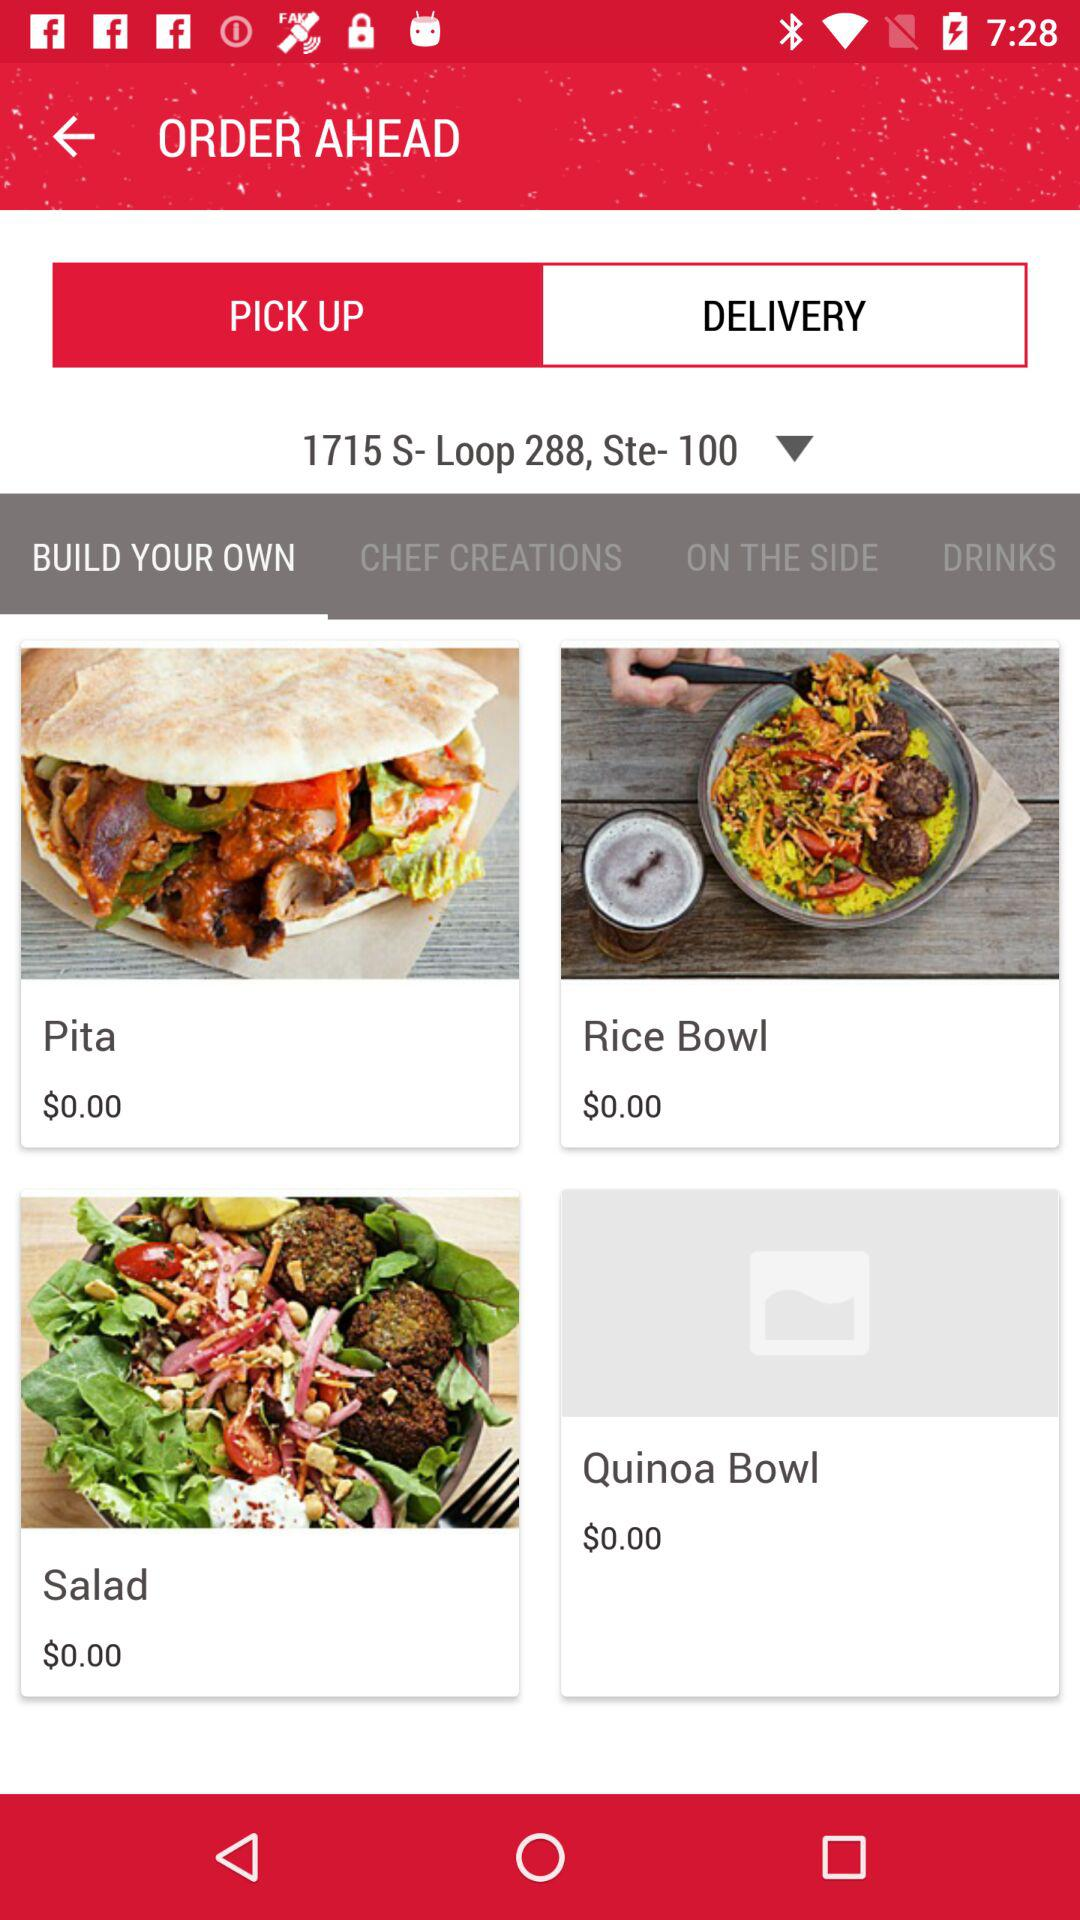Which tab is selected? The selected tab is "PICK UP". 